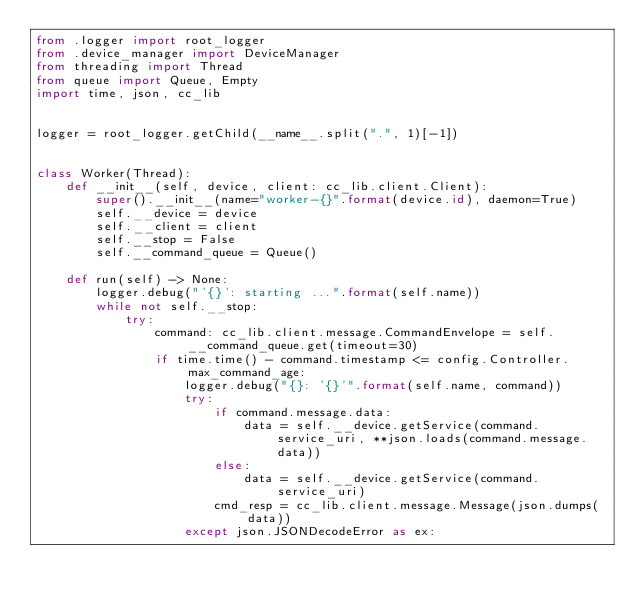<code> <loc_0><loc_0><loc_500><loc_500><_Python_>from .logger import root_logger
from .device_manager import DeviceManager
from threading import Thread
from queue import Queue, Empty
import time, json, cc_lib


logger = root_logger.getChild(__name__.split(".", 1)[-1])


class Worker(Thread):
    def __init__(self, device, client: cc_lib.client.Client):
        super().__init__(name="worker-{}".format(device.id), daemon=True)
        self.__device = device
        self.__client = client
        self.__stop = False
        self.__command_queue = Queue()

    def run(self) -> None:
        logger.debug("'{}': starting ...".format(self.name))
        while not self.__stop:
            try:
                command: cc_lib.client.message.CommandEnvelope = self.__command_queue.get(timeout=30)
                if time.time() - command.timestamp <= config.Controller.max_command_age:
                    logger.debug("{}: '{}'".format(self.name, command))
                    try:
                        if command.message.data:
                            data = self.__device.getService(command.service_uri, **json.loads(command.message.data))
                        else:
                            data = self.__device.getService(command.service_uri)
                        cmd_resp = cc_lib.client.message.Message(json.dumps(data))
                    except json.JSONDecodeError as ex:</code> 